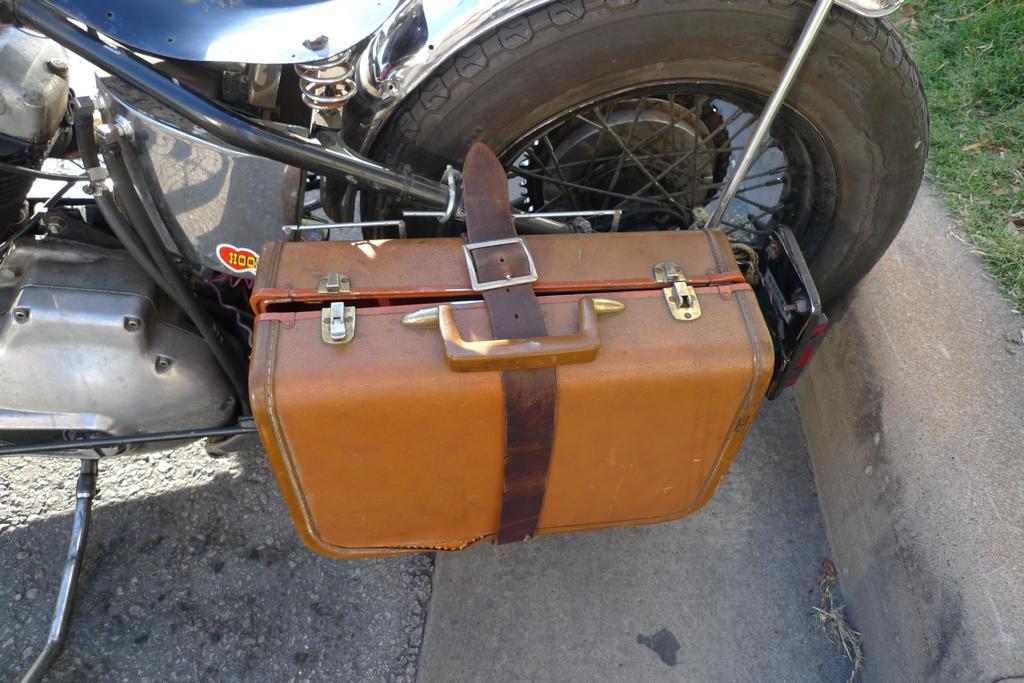Could you give a brief overview of what you see in this image? There is a box beside the bike tyre. 